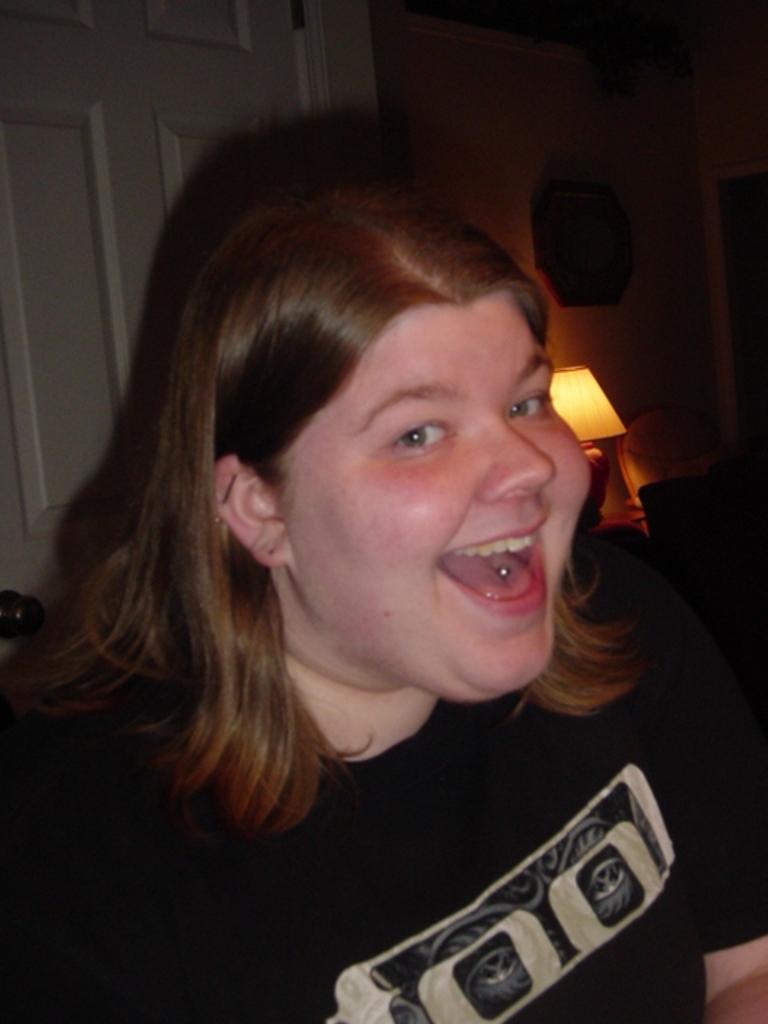Can you describe this image briefly? In this image we can see a lady smiling. She is wearing a black shirt. In the background there is a wall, door and a lamp. 